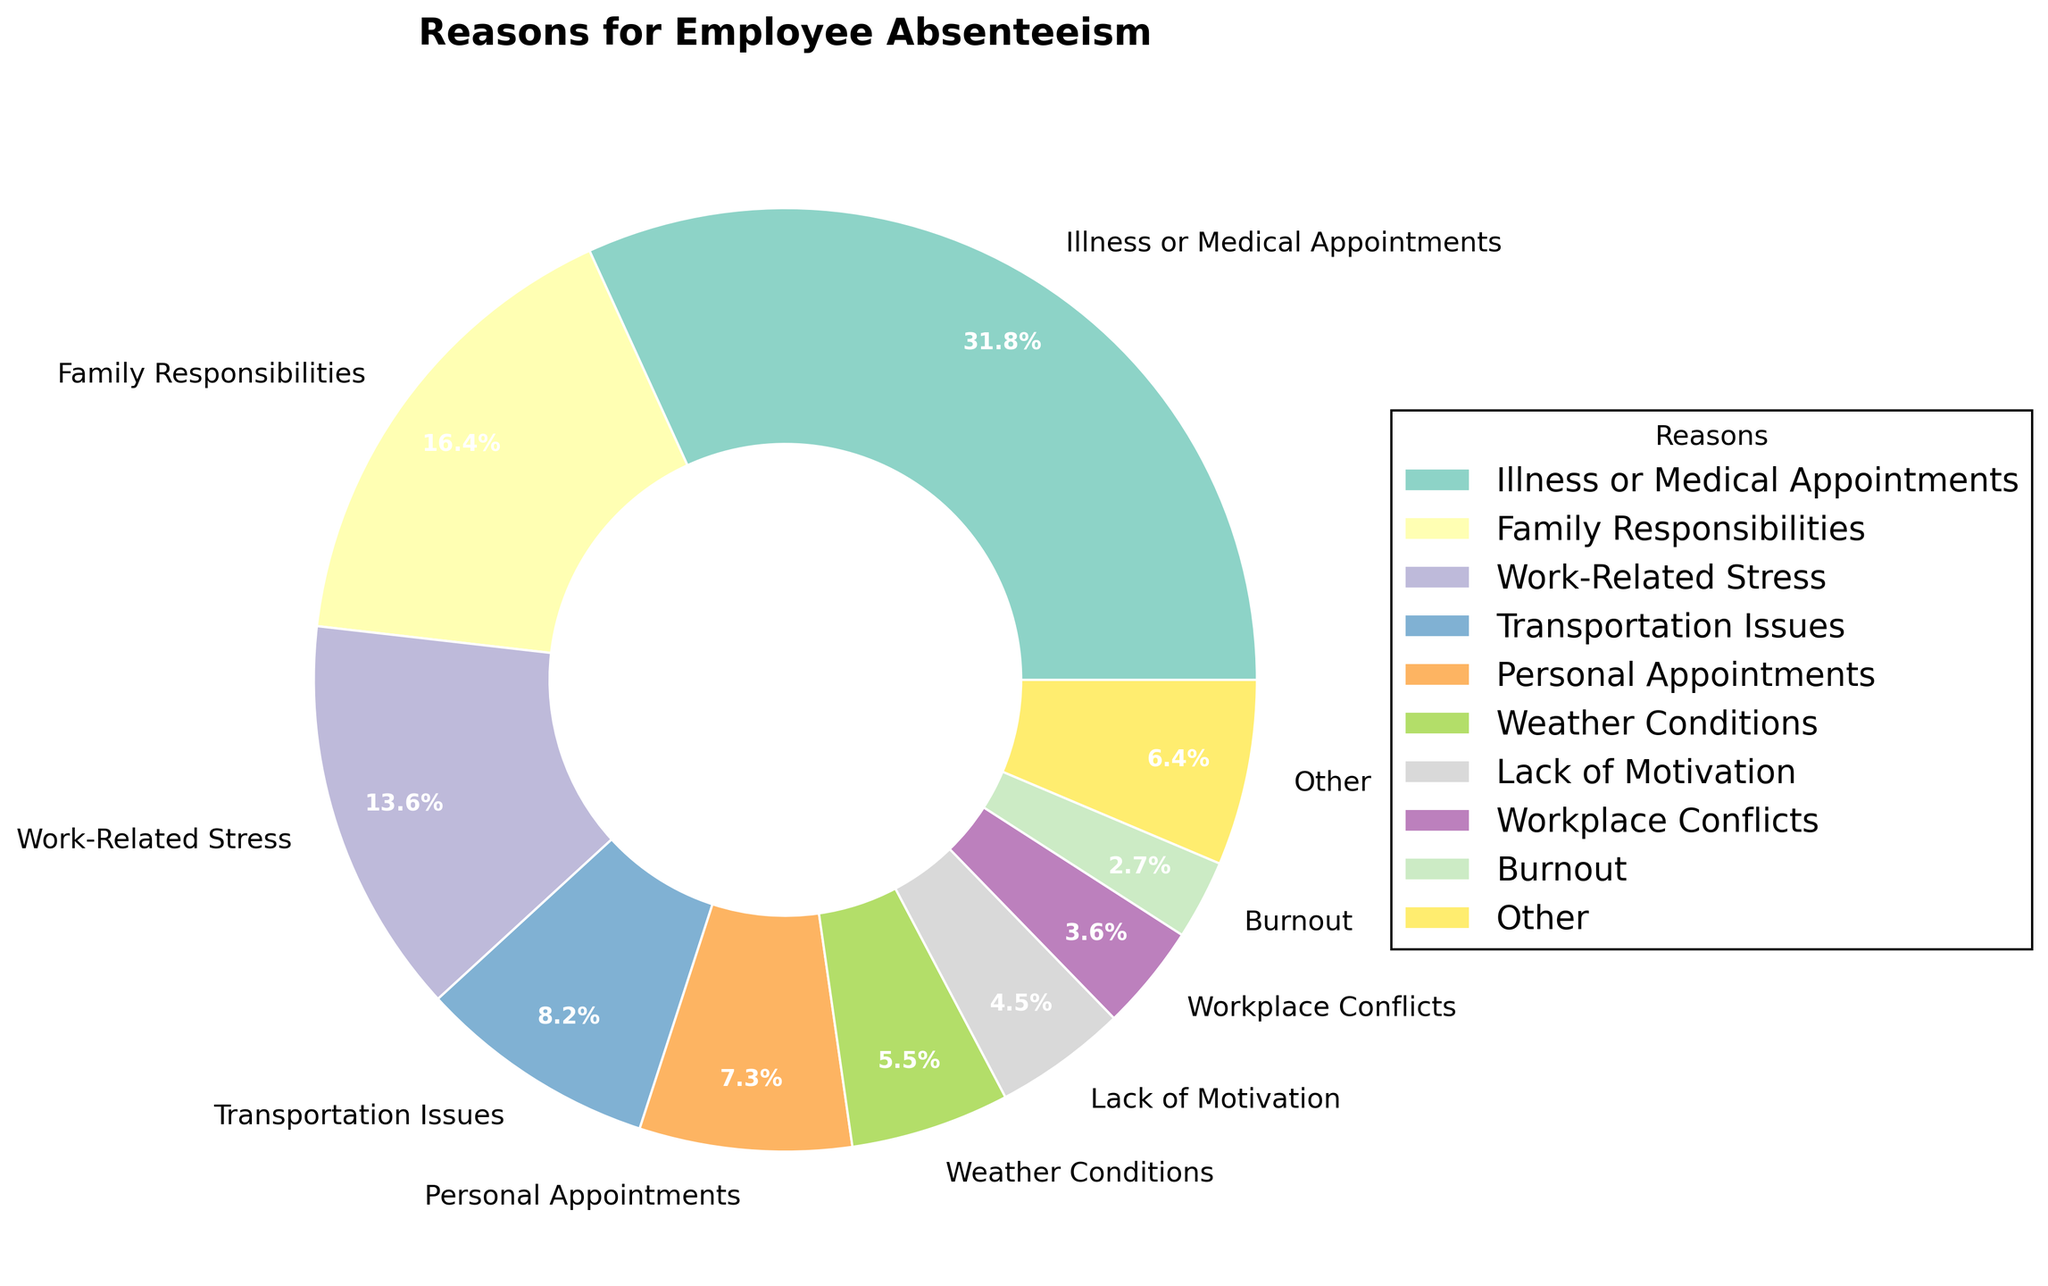What is the most common reason for employee absenteeism? The pie chart shows that "Illness or Medical Appointments" has the largest slice with a percentage of 35%, indicating it is the most common reason.
Answer: Illness or Medical Appointments What is the sum of percentages for the three least common reasons combined? The three least common reasons under "Other" - Professional Development, Bereavement, and Substance Abuse each have 2%, and Jury Duty, Military Service each have 1%. Summing these, we get 2 + 2 + 1 + 1 + 1 ≈ 7%.
Answer: 7% Which reason for absenteeism is more common: Weather Conditions or Personal Appointments? By comparing the sizes of the slices, Personal Appointments (8%) is greater than Weather Conditions (6%).
Answer: Personal Appointments What percentage of absenteeism is due to work-related issues (Work-Related Stress and Workplace Conflicts)? Adding Work-Related Stress (15%) and Workplace Conflicts (4%), we get 15 + 4 = 19%.
Answer: 19% How many reasons are grouped under the "Other" category? The "Other" category includes all reasons below the 3% threshold: Professional Development, Bereavement, Substance Abuse, Jury Duty, Military Service, totaling 5 reasons.
Answer: 5 Calculate the percentage difference between Illness or Medical Appointments and Family Responsibilities. Subtract Family Responsibilities (18%) from Illness or Medical Appointments (35%), resulting in 35 - 18 = 17%.
Answer: 17% What is the cumulative percentage for Family Responsibilities and Work-Related Stress? Adding Family Responsibilities (18%) and Work-Related Stress (15%), we get 18 + 15 = 33%.
Answer: 33% Compare the percentage of absenteeism caused by Work-Related Stress to the sum of Weather Conditions and Lack of Motivation. Which is greater and by how much? Work-Related Stress is 15%. Weather Conditions (6%) + Lack of Motivation (5%) = 11%. The difference is 15 - 11 = 4%. Therefore, Work-Related Stress is greater by 4%.
Answer: Work-Related Stress, by 4% What is the smallest single reason for absenteeism, not included in "Other"? "Burnout" is directly labeled with 3%, which is the smallest single reason shown outside the "Other" category.
Answer: Burnout What is the visual indication for differentiating the "Other" category in the pie chart? "Other" is labeled and grouped as a single slice, distinguished by its placement and color relative to the larger reasons.
Answer: Grouped slice and color 